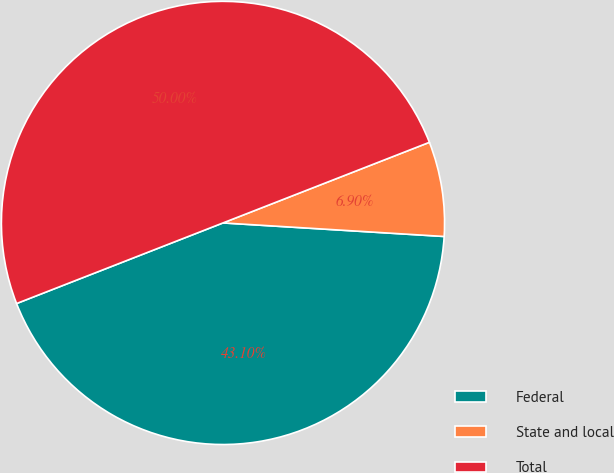Convert chart. <chart><loc_0><loc_0><loc_500><loc_500><pie_chart><fcel>Federal<fcel>State and local<fcel>Total<nl><fcel>43.1%<fcel>6.9%<fcel>50.0%<nl></chart> 